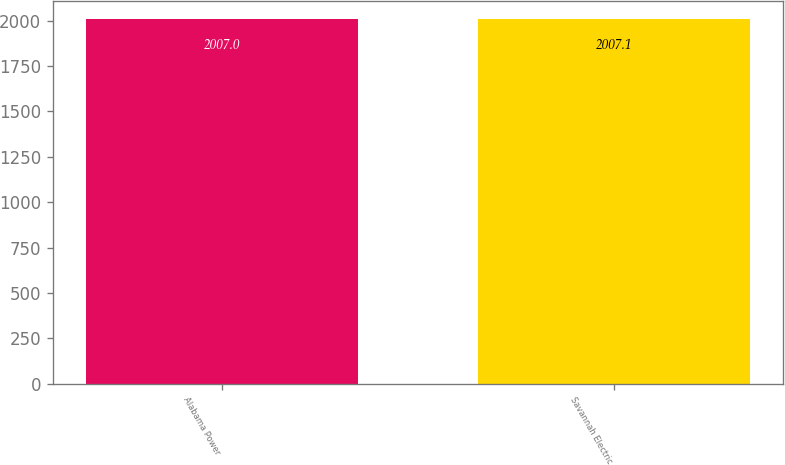<chart> <loc_0><loc_0><loc_500><loc_500><bar_chart><fcel>Alabama Power<fcel>Savannah Electric<nl><fcel>2007<fcel>2007.1<nl></chart> 